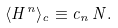Convert formula to latex. <formula><loc_0><loc_0><loc_500><loc_500>\langle H ^ { n } \rangle _ { c } \equiv c _ { n } \, N .</formula> 